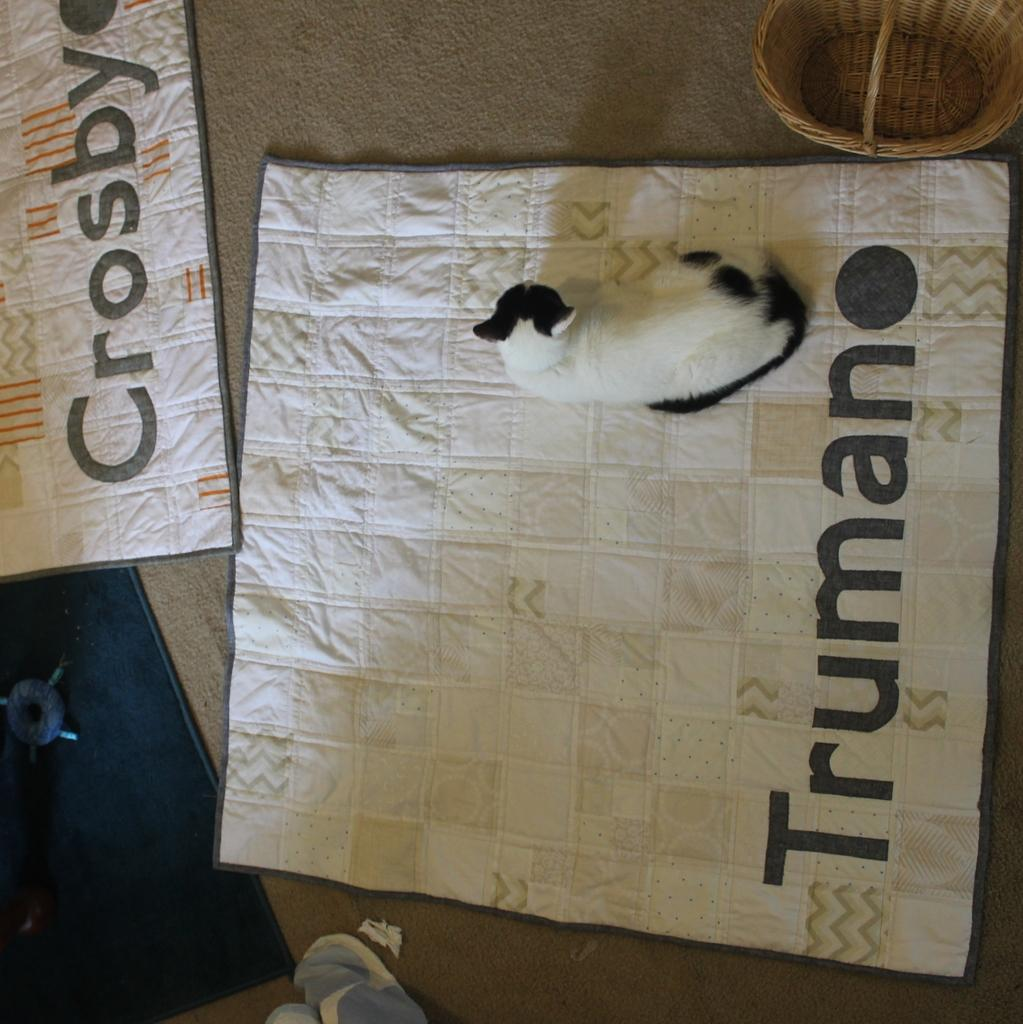What is the main subject in the center of the image? There is a cat in the center of the image. What is the cat sitting on? The cat is on a carpet. Where is the basket located in the image? The basket is in the top right corner of the image. What can be seen in the background of the image? There is cloth visible in the background of the image, and there is also an object present. Who is the creator of the feather seen in the image? There is no feather present in the image, so it is not possible to determine who its creator might be. 